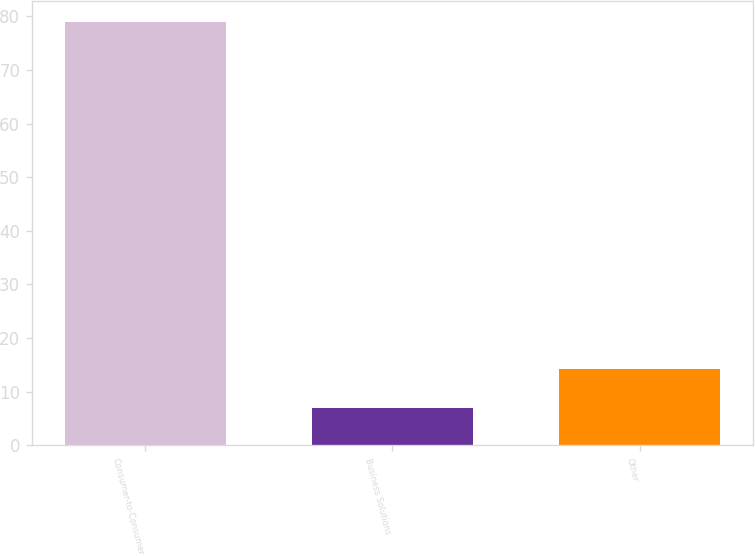Convert chart to OTSL. <chart><loc_0><loc_0><loc_500><loc_500><bar_chart><fcel>Consumer-to-Consumer<fcel>Business Solutions<fcel>Other<nl><fcel>79<fcel>7<fcel>14.2<nl></chart> 